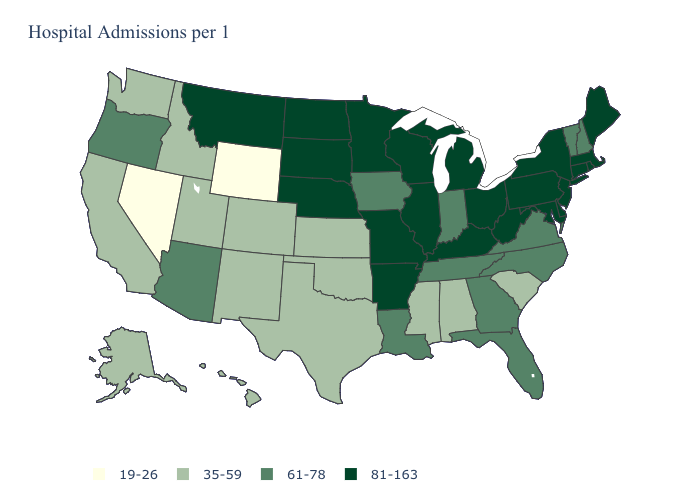What is the value of Mississippi?
Give a very brief answer. 35-59. Name the states that have a value in the range 81-163?
Answer briefly. Arkansas, Connecticut, Delaware, Illinois, Kentucky, Maine, Maryland, Massachusetts, Michigan, Minnesota, Missouri, Montana, Nebraska, New Jersey, New York, North Dakota, Ohio, Pennsylvania, Rhode Island, South Dakota, West Virginia, Wisconsin. Name the states that have a value in the range 19-26?
Keep it brief. Nevada, Wyoming. Does Wyoming have the lowest value in the USA?
Write a very short answer. Yes. Does Florida have a higher value than Indiana?
Keep it brief. No. Among the states that border Mississippi , which have the lowest value?
Quick response, please. Alabama. What is the value of Texas?
Short answer required. 35-59. Name the states that have a value in the range 35-59?
Keep it brief. Alabama, Alaska, California, Colorado, Hawaii, Idaho, Kansas, Mississippi, New Mexico, Oklahoma, South Carolina, Texas, Utah, Washington. Is the legend a continuous bar?
Be succinct. No. How many symbols are there in the legend?
Concise answer only. 4. What is the lowest value in the USA?
Quick response, please. 19-26. Does New York have the highest value in the USA?
Be succinct. Yes. Name the states that have a value in the range 61-78?
Quick response, please. Arizona, Florida, Georgia, Indiana, Iowa, Louisiana, New Hampshire, North Carolina, Oregon, Tennessee, Vermont, Virginia. What is the highest value in states that border New York?
Answer briefly. 81-163. Does Colorado have a lower value than Florida?
Give a very brief answer. Yes. 